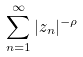<formula> <loc_0><loc_0><loc_500><loc_500>\sum _ { n = 1 } ^ { \infty } | z _ { n } | ^ { - \rho }</formula> 